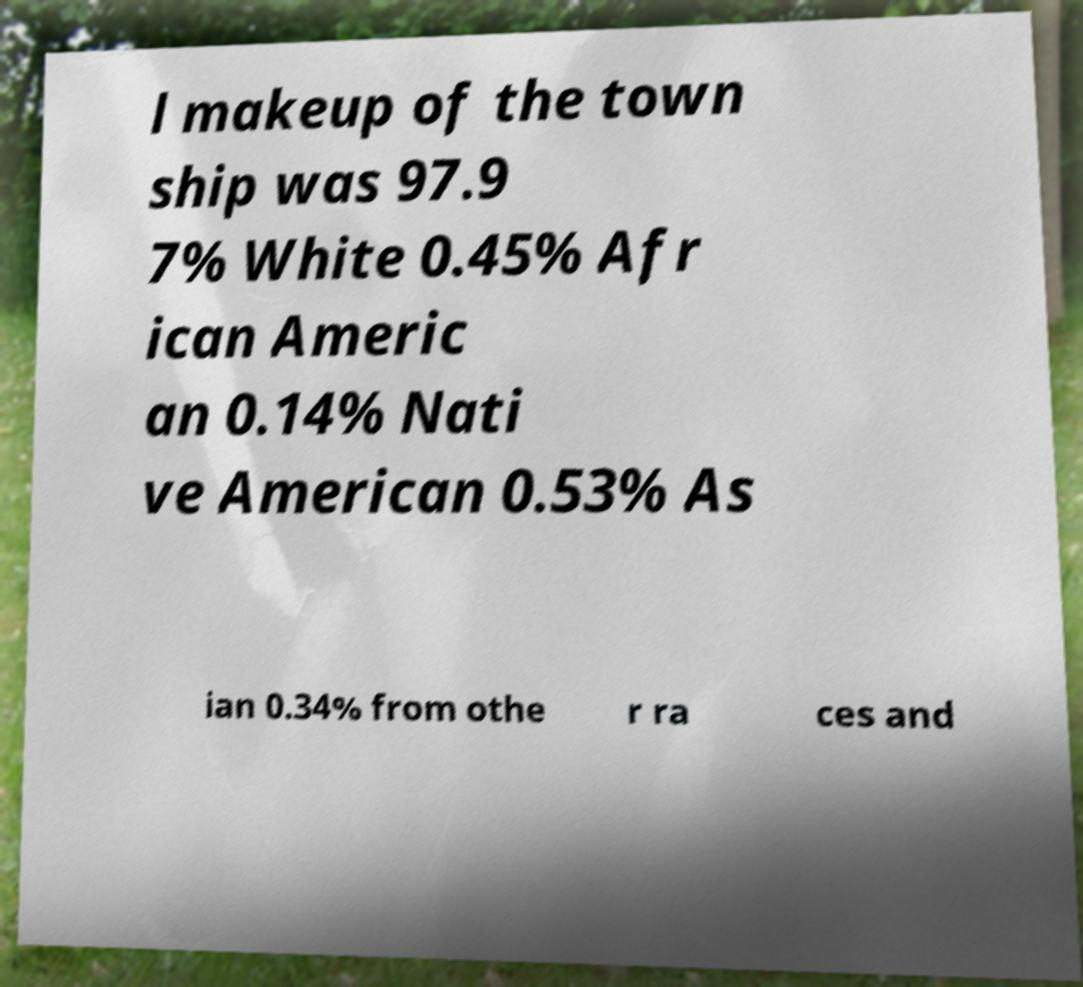Can you read and provide the text displayed in the image?This photo seems to have some interesting text. Can you extract and type it out for me? l makeup of the town ship was 97.9 7% White 0.45% Afr ican Americ an 0.14% Nati ve American 0.53% As ian 0.34% from othe r ra ces and 